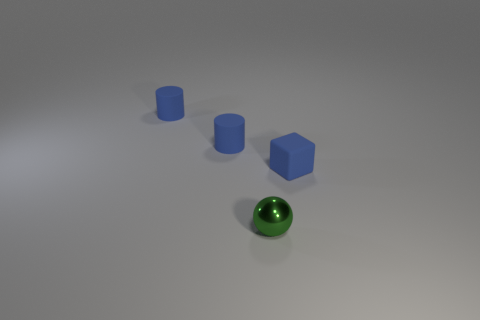Subtract all cubes. How many objects are left? 3 Subtract 1 cubes. How many cubes are left? 0 Add 2 tiny blue matte objects. How many objects exist? 6 Subtract 1 blue cylinders. How many objects are left? 3 Subtract all purple cylinders. Subtract all green balls. How many cylinders are left? 2 Subtract all big matte things. Subtract all blue rubber cubes. How many objects are left? 3 Add 1 small blue rubber cylinders. How many small blue rubber cylinders are left? 3 Add 1 blue things. How many blue things exist? 4 